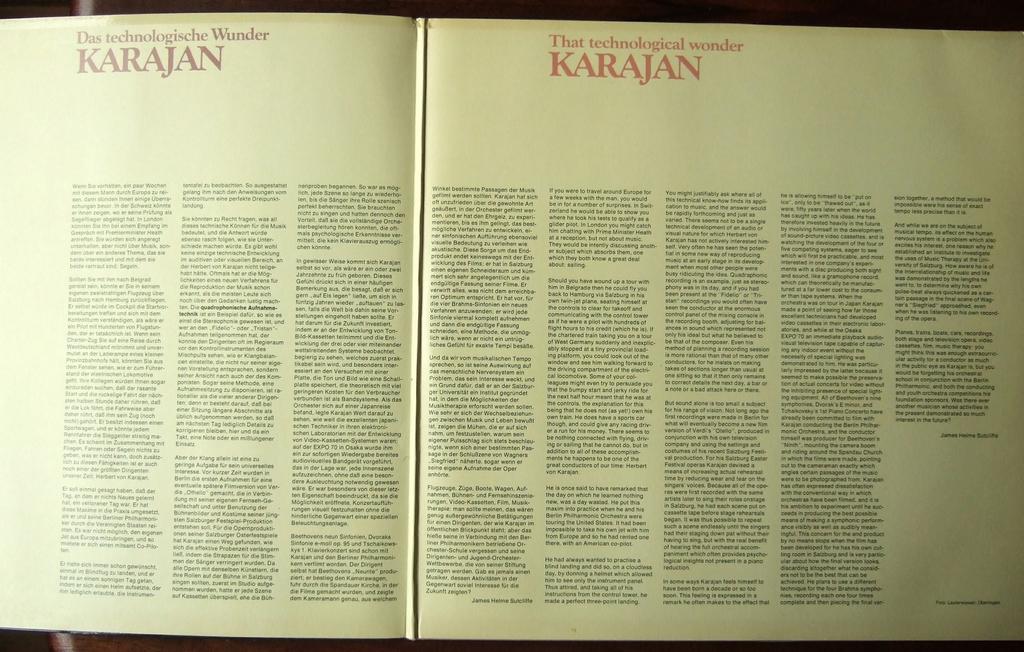What is the technological wonder printed at the top of the page?
Offer a terse response. Karajan. 